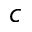<formula> <loc_0><loc_0><loc_500><loc_500>c</formula> 